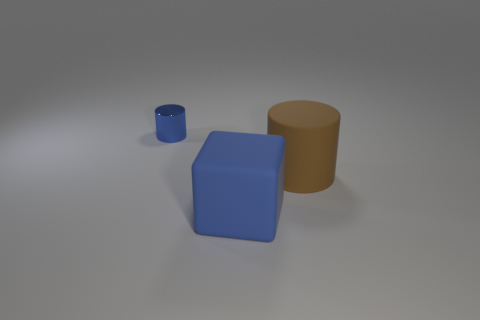Is there any indication of the size scale between the objects? While the exact dimensions are not provided, we can infer their relative sizes through comparison. The blue cube appears to be of medium size, the brown cylinder is the largest, and the blue cylinder is the smallest object. 